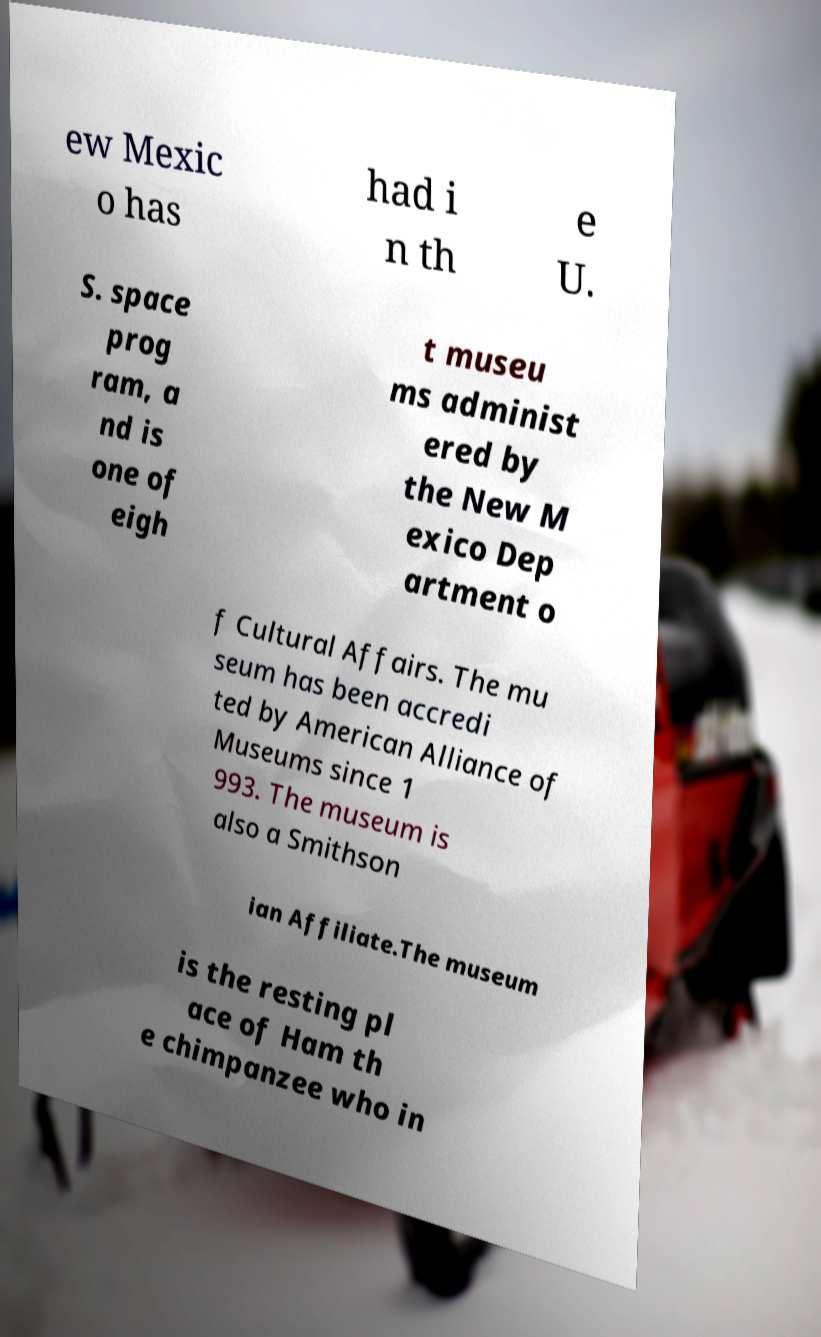What messages or text are displayed in this image? I need them in a readable, typed format. ew Mexic o has had i n th e U. S. space prog ram, a nd is one of eigh t museu ms administ ered by the New M exico Dep artment o f Cultural Affairs. The mu seum has been accredi ted by American Alliance of Museums since 1 993. The museum is also a Smithson ian Affiliate.The museum is the resting pl ace of Ham th e chimpanzee who in 